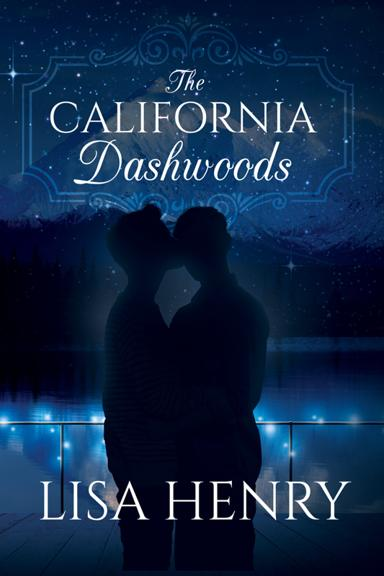How does the design of the book cover reflect the genre or themes of the book? The cover design, with its focus on a romantic silhouette against a mystical backdrop, suggests themes of love, relationships, and possibly challenges faced by the characters, typical of a romantic or dramatic novel. 